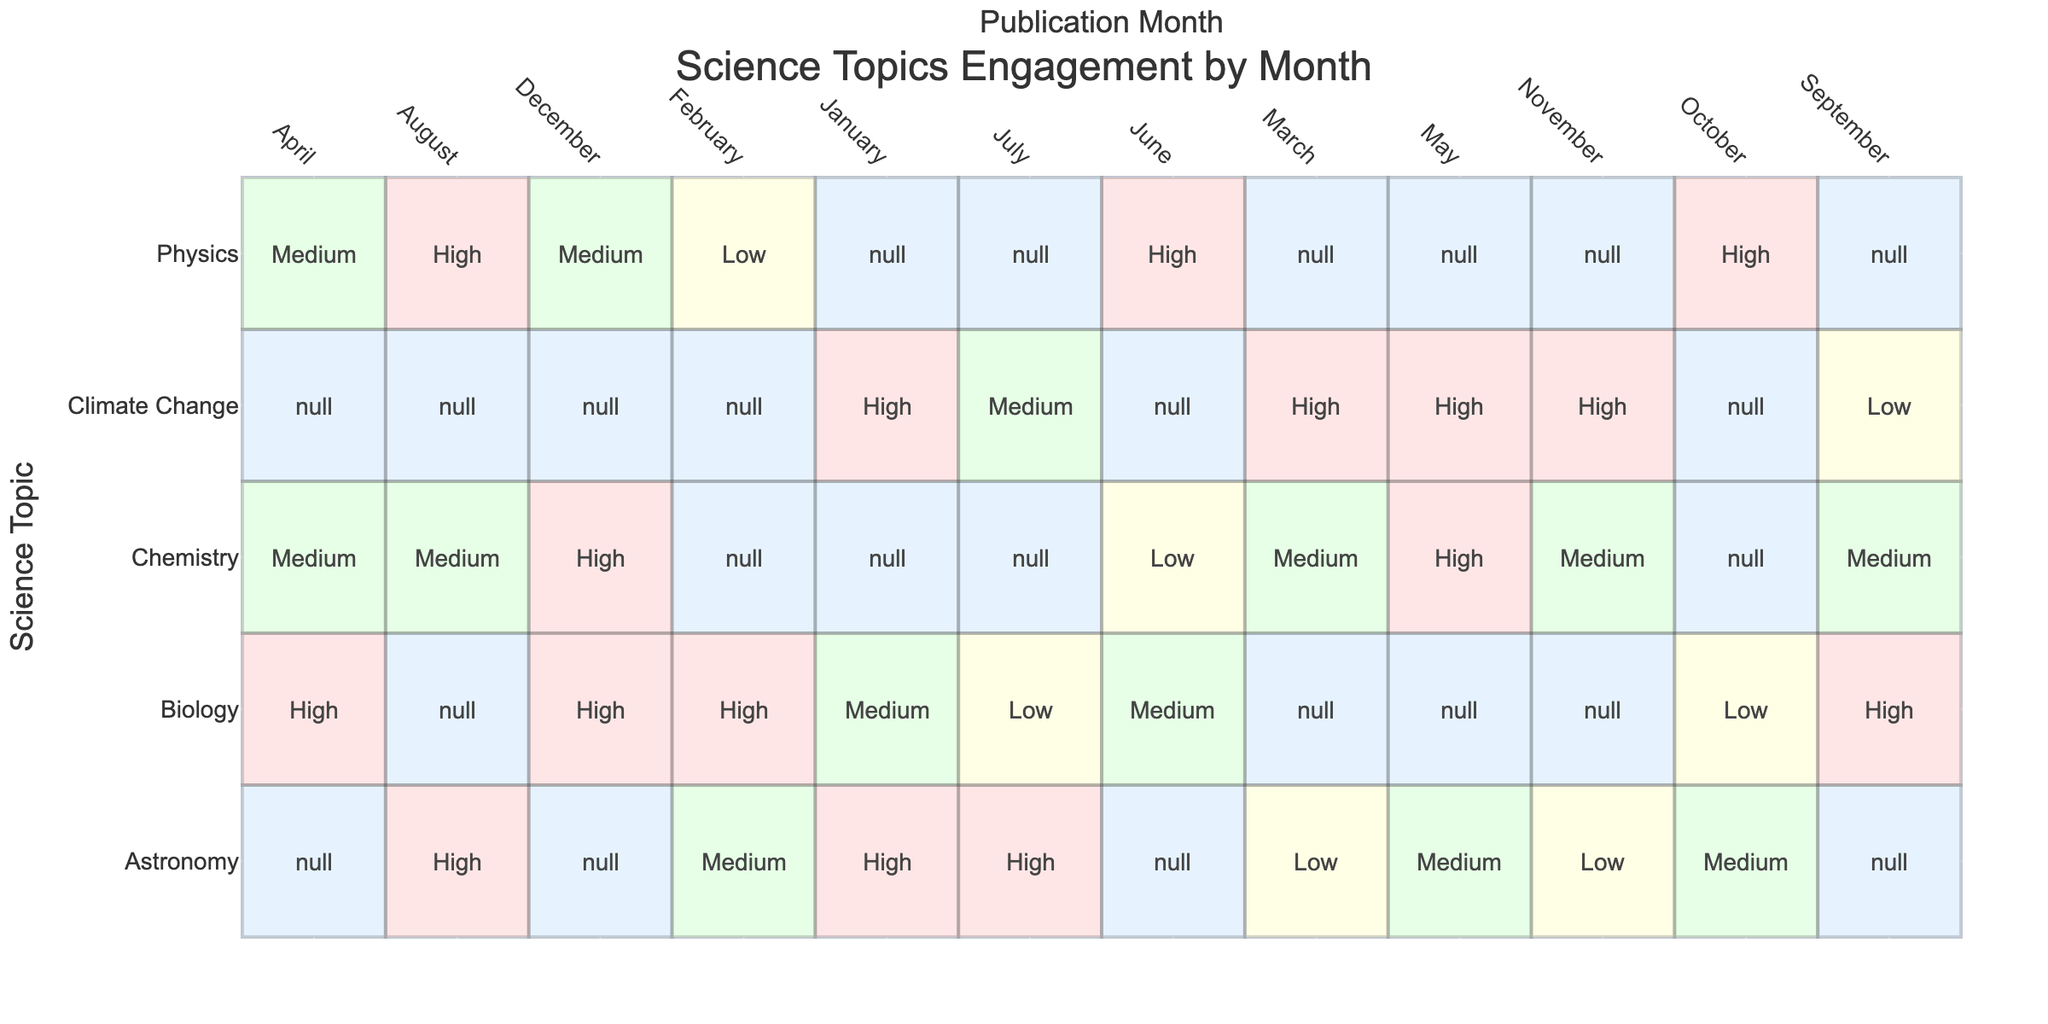What is the most popular science topic in January? In January, the science topics listed are Astronomy, Biology, and Climate Change. Among these, both Astronomy and Climate Change have a High engagement level, but Astronomy appears first in the list, making it effectively the most popular.
Answer: Astronomy How many Science Topics have a High engagement level in April? In April, the science topics are Biology, Physics, and Chemistry. Among them, Biology has a High engagement level, while Physics and Chemistry have Medium engagement levels. Therefore, there is only one topic with High engagement level in April.
Answer: 1 Which engagement level is least common in July? In July, the science topics listed are Astronomy, Climate Change, and Biology. Astronomy has a High engagement level, Climate Change has Medium, and Biology has Low. The least common engagement level is Low.
Answer: Low Are there any months where Chemistry had the highest engagement level? Looking at the table for Chemistry, it shows High engagement level in May and December. However, it never had the highest engagement level when compared with other topics in these months. Thus, the answer is no.
Answer: No What is the total number of High engagement entries for Climate Change across all months? The Climate Change entries occur in January (High), February (Low), March (High), May (High), July (Medium), September (Low), and November (High). Counting only the High entries gives a total of 4 (January, March, May, and November).
Answer: 4 What is the average engagement level of Physics across the months? Physics has the engagement levels in the months as follows: February (Low), April (Medium), June (High), August (High), October (High). Assigning numerical values (Low=3, Medium=2, High=1, we consider lower numbers as better), we find the values 3, 2, 1, 1, and 1. Summing them gives 3 + 2 + 1 + 1 + 1 = 8. There are 5 entries, thus the average is 8/5 = 1.6, which corresponds to a Medium level after rounding.
Answer: Medium Which month had the highest count of Medium engagement levels across all topics? Analyzing each month's entries, we find April (2), February (1), March (1), June (1), and August (1). Only April had the highest count of Medium entries, making it the winner.
Answer: April Are Biology and Astronomy the only topics with a High engagement level in October? In October, both Biology and Physics have entries, where Biology has a Low engagement level and Physics a High. Therefore, Biology cannot be counted in High engagements, and Astronomy is not mentioned. The answer is no.
Answer: No 